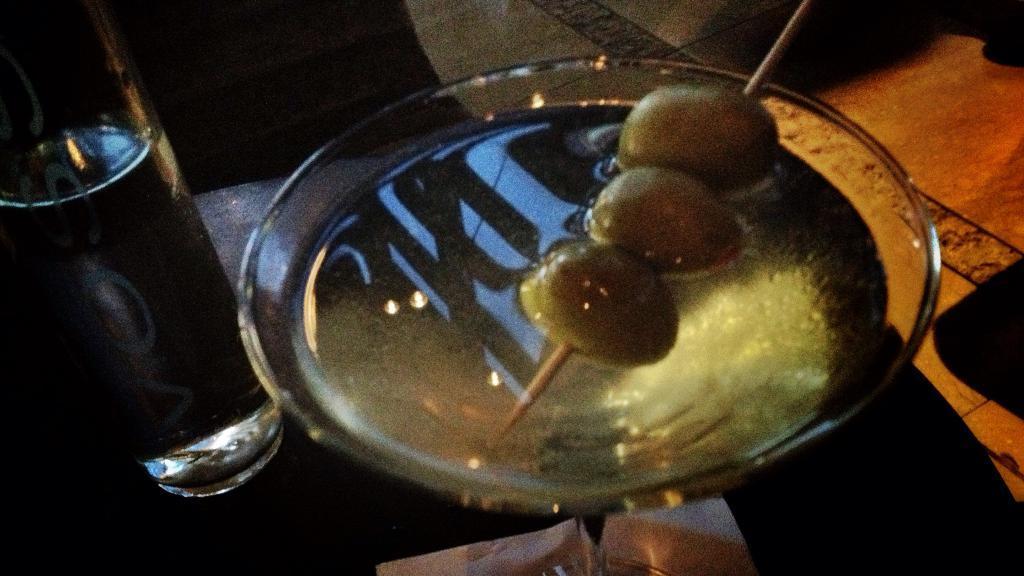How would you summarize this image in a sentence or two? In the image there is a bowl with soup and pickles prick to a tooth prick along with water bottle on a table. 